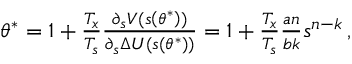<formula> <loc_0><loc_0><loc_500><loc_500>\begin{array} { r } { \theta ^ { * } = 1 + \frac { T _ { x } } { T _ { s } } \frac { \partial _ { s } V ( s \left ( \theta ^ { * } \right ) ) } { \partial _ { s } \Delta U ( s \left ( \theta ^ { * } \right ) ) } = 1 + \frac { T _ { x } } { T _ { s } } \frac { a n } { b k } s ^ { n - k } \, , } \end{array}</formula> 